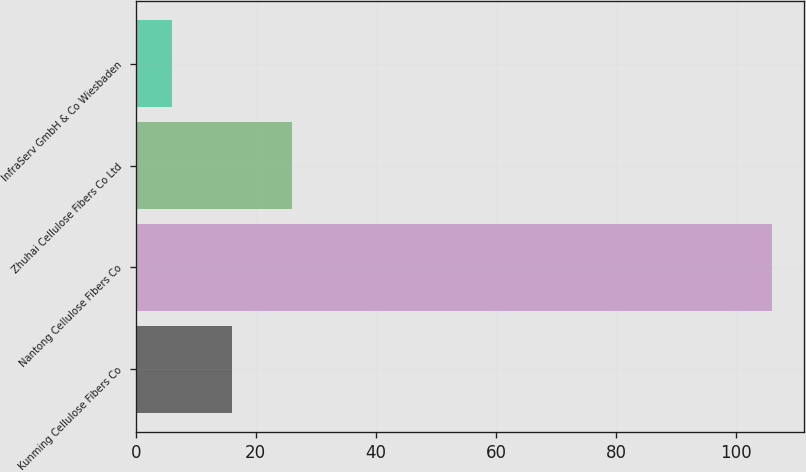Convert chart. <chart><loc_0><loc_0><loc_500><loc_500><bar_chart><fcel>Kunming Cellulose Fibers Co<fcel>Nantong Cellulose Fibers Co<fcel>Zhuhai Cellulose Fibers Co Ltd<fcel>InfraServ GmbH & Co Wiesbaden<nl><fcel>16<fcel>106<fcel>26<fcel>6<nl></chart> 